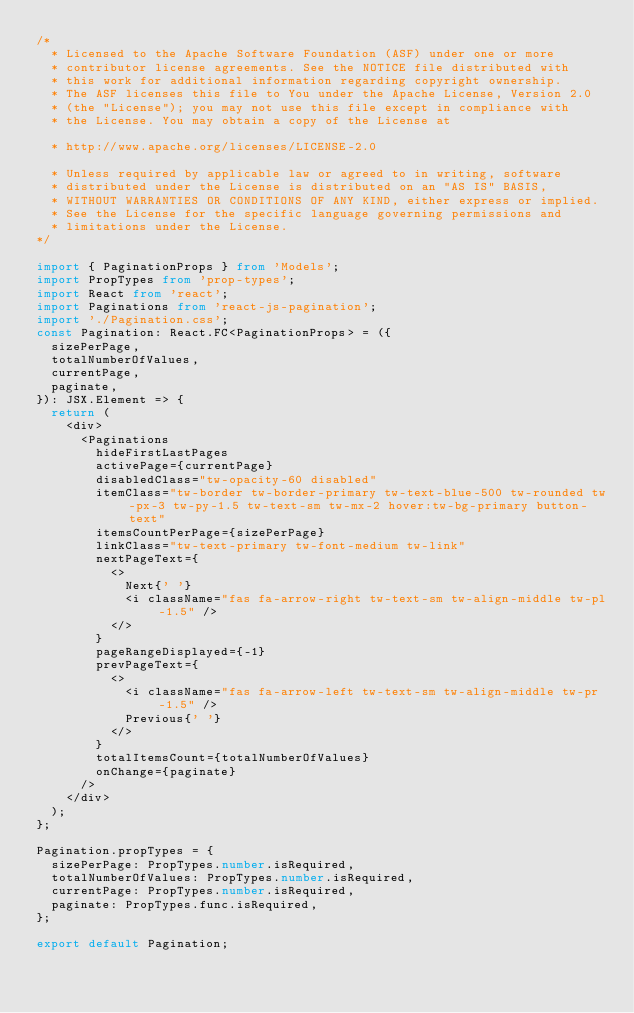Convert code to text. <code><loc_0><loc_0><loc_500><loc_500><_TypeScript_>/*
  * Licensed to the Apache Software Foundation (ASF) under one or more
  * contributor license agreements. See the NOTICE file distributed with
  * this work for additional information regarding copyright ownership.
  * The ASF licenses this file to You under the Apache License, Version 2.0
  * (the "License"); you may not use this file except in compliance with
  * the License. You may obtain a copy of the License at

  * http://www.apache.org/licenses/LICENSE-2.0

  * Unless required by applicable law or agreed to in writing, software
  * distributed under the License is distributed on an "AS IS" BASIS,
  * WITHOUT WARRANTIES OR CONDITIONS OF ANY KIND, either express or implied.
  * See the License for the specific language governing permissions and
  * limitations under the License.
*/

import { PaginationProps } from 'Models';
import PropTypes from 'prop-types';
import React from 'react';
import Paginations from 'react-js-pagination';
import './Pagination.css';
const Pagination: React.FC<PaginationProps> = ({
  sizePerPage,
  totalNumberOfValues,
  currentPage,
  paginate,
}): JSX.Element => {
  return (
    <div>
      <Paginations
        hideFirstLastPages
        activePage={currentPage}
        disabledClass="tw-opacity-60 disabled"
        itemClass="tw-border tw-border-primary tw-text-blue-500 tw-rounded tw-px-3 tw-py-1.5 tw-text-sm tw-mx-2 hover:tw-bg-primary button-text"
        itemsCountPerPage={sizePerPage}
        linkClass="tw-text-primary tw-font-medium tw-link"
        nextPageText={
          <>
            Next{' '}
            <i className="fas fa-arrow-right tw-text-sm tw-align-middle tw-pl-1.5" />
          </>
        }
        pageRangeDisplayed={-1}
        prevPageText={
          <>
            <i className="fas fa-arrow-left tw-text-sm tw-align-middle tw-pr-1.5" />
            Previous{' '}
          </>
        }
        totalItemsCount={totalNumberOfValues}
        onChange={paginate}
      />
    </div>
  );
};

Pagination.propTypes = {
  sizePerPage: PropTypes.number.isRequired,
  totalNumberOfValues: PropTypes.number.isRequired,
  currentPage: PropTypes.number.isRequired,
  paginate: PropTypes.func.isRequired,
};

export default Pagination;
</code> 